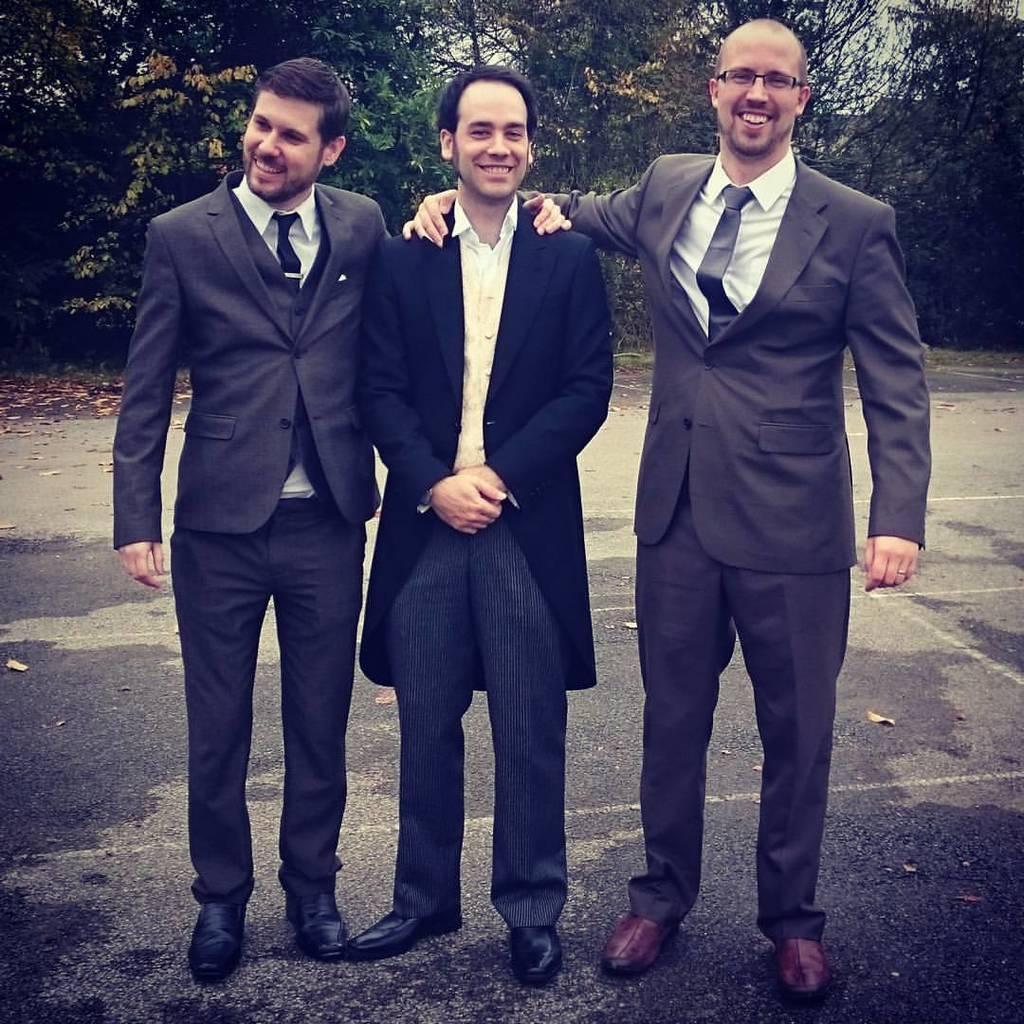In one or two sentences, can you explain what this image depicts? This image is taken outdoors. In the background there are a few trees and plants. At the bottom of the image there is a road. In the middle of the image three men are standing on the road and they are with smiling faces. They have worn suits, shirts and ties. 